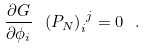<formula> <loc_0><loc_0><loc_500><loc_500>\frac { \partial G } { \partial \phi _ { i } } \ { \left ( P _ { N } \right ) _ { i } } ^ { j } = 0 \ .</formula> 